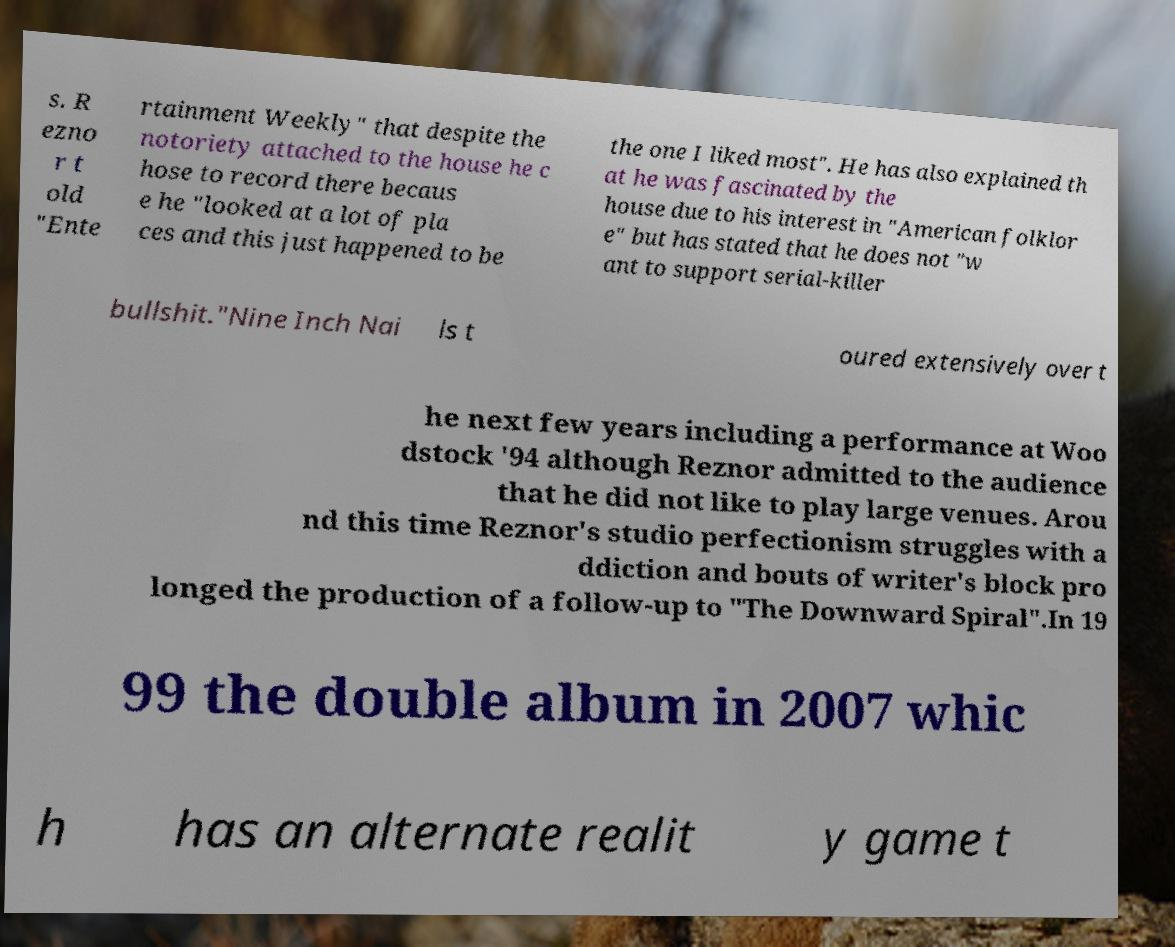Can you read and provide the text displayed in the image?This photo seems to have some interesting text. Can you extract and type it out for me? s. R ezno r t old "Ente rtainment Weekly" that despite the notoriety attached to the house he c hose to record there becaus e he "looked at a lot of pla ces and this just happened to be the one I liked most". He has also explained th at he was fascinated by the house due to his interest in "American folklor e" but has stated that he does not "w ant to support serial-killer bullshit."Nine Inch Nai ls t oured extensively over t he next few years including a performance at Woo dstock '94 although Reznor admitted to the audience that he did not like to play large venues. Arou nd this time Reznor's studio perfectionism struggles with a ddiction and bouts of writer's block pro longed the production of a follow-up to "The Downward Spiral".In 19 99 the double album in 2007 whic h has an alternate realit y game t 